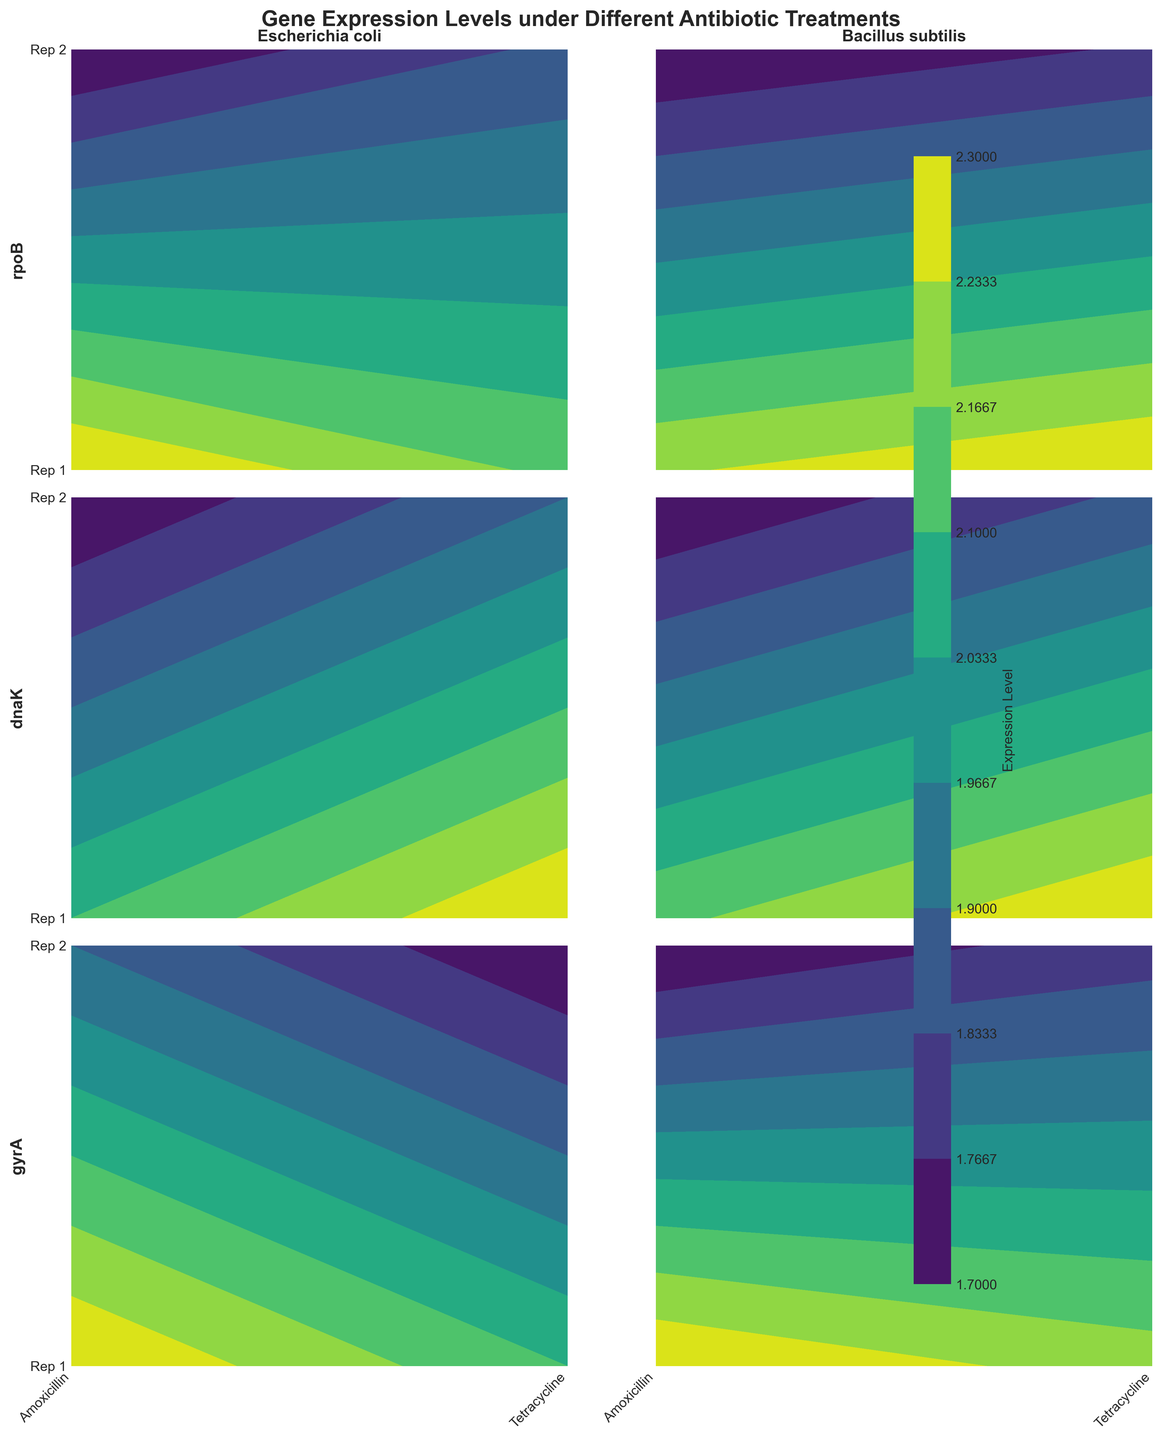What is the title of the figure? The title of the figure is displayed at the top, it is "Gene Expression Levels under Different Antibiotic Treatments".
Answer: Gene Expression Levels under Different Antibiotic Treatments Which gene shows the highest expression level in Bacillus_subtilis under Amoxicillin treatment? Look at the Bacillus_subtilis column and identify the contour plot with Amoxicillin as the x-axis label. Find the contour plot corresponding to the gene with the darkest color, indicating the highest expression level.
Answer: gyrA What is the range of expression levels for Escherichia_coli treated with Tetracycline? Focus on the Escherichia_coli column and find the contour plots with Tetracycline as the x-axis label. Observe the color scale to determine the range of values represented.
Answer: 0.4 to 1.1 How does the expression level of rpoB in Escherichia_coli compare to dnaK in Bacillus_subtilis under Amoxicillin treatment? Identify the contour plots for rpoB in Escherichia_coli and dnaK in Bacillus_subtilis. Compare the color intensities or contour values under the Amoxicillin label to determine which is higher.
Answer: Bacillus_subtilis dnaK has higher expression Which strain shows a more significant difference in expression levels between Amoxicillin and Tetracycline treatments for gyrA gene? Locate the contour plots for gyrA in both strains. Compare the differences in expression levels between Amoxicillin and Tetracycline treatments for each strain by observing the color changes.
Answer: Bacillus_subtilis What are the expression levels for dnaK in Escherichia_coli under Amoxicillin treatment? Locate the contour plot for dnaK in Escherichia_coli. Look at the x-axis label for Amoxicillin and identify the corresponding points on the contour plot.
Answer: 0.6 and 0.7 Which gene in Escherichia_coli has the lowest variation in expression levels between the two antibiotics? Identify the contour plots for Escherichia_coli. For each gene, observe the variation in expression levels between Amoxicillin and Tetracycline by comparing the contour lines or color changes for both antibiotics.
Answer: gyrA Is there any gene in Bacillus_subtilis that has higher expression in Tetracycline than in Amoxicillin? Check all contour plots for Bacillus_subtilis. Compare the expression levels for each gene under Tetracycline and Amoxicillin by observing the contour lines or color intensities for both antibiotics.
Answer: No What is the expression level for gyrA in both replicates of Bacillus_subtilis under Tetracycline treatment? Locate the contour plot for gyrA in Bacillus_subtilis and identify the values represented for the Tetracycline label on the x-axis.
Answer: 1.7 and 1.8 